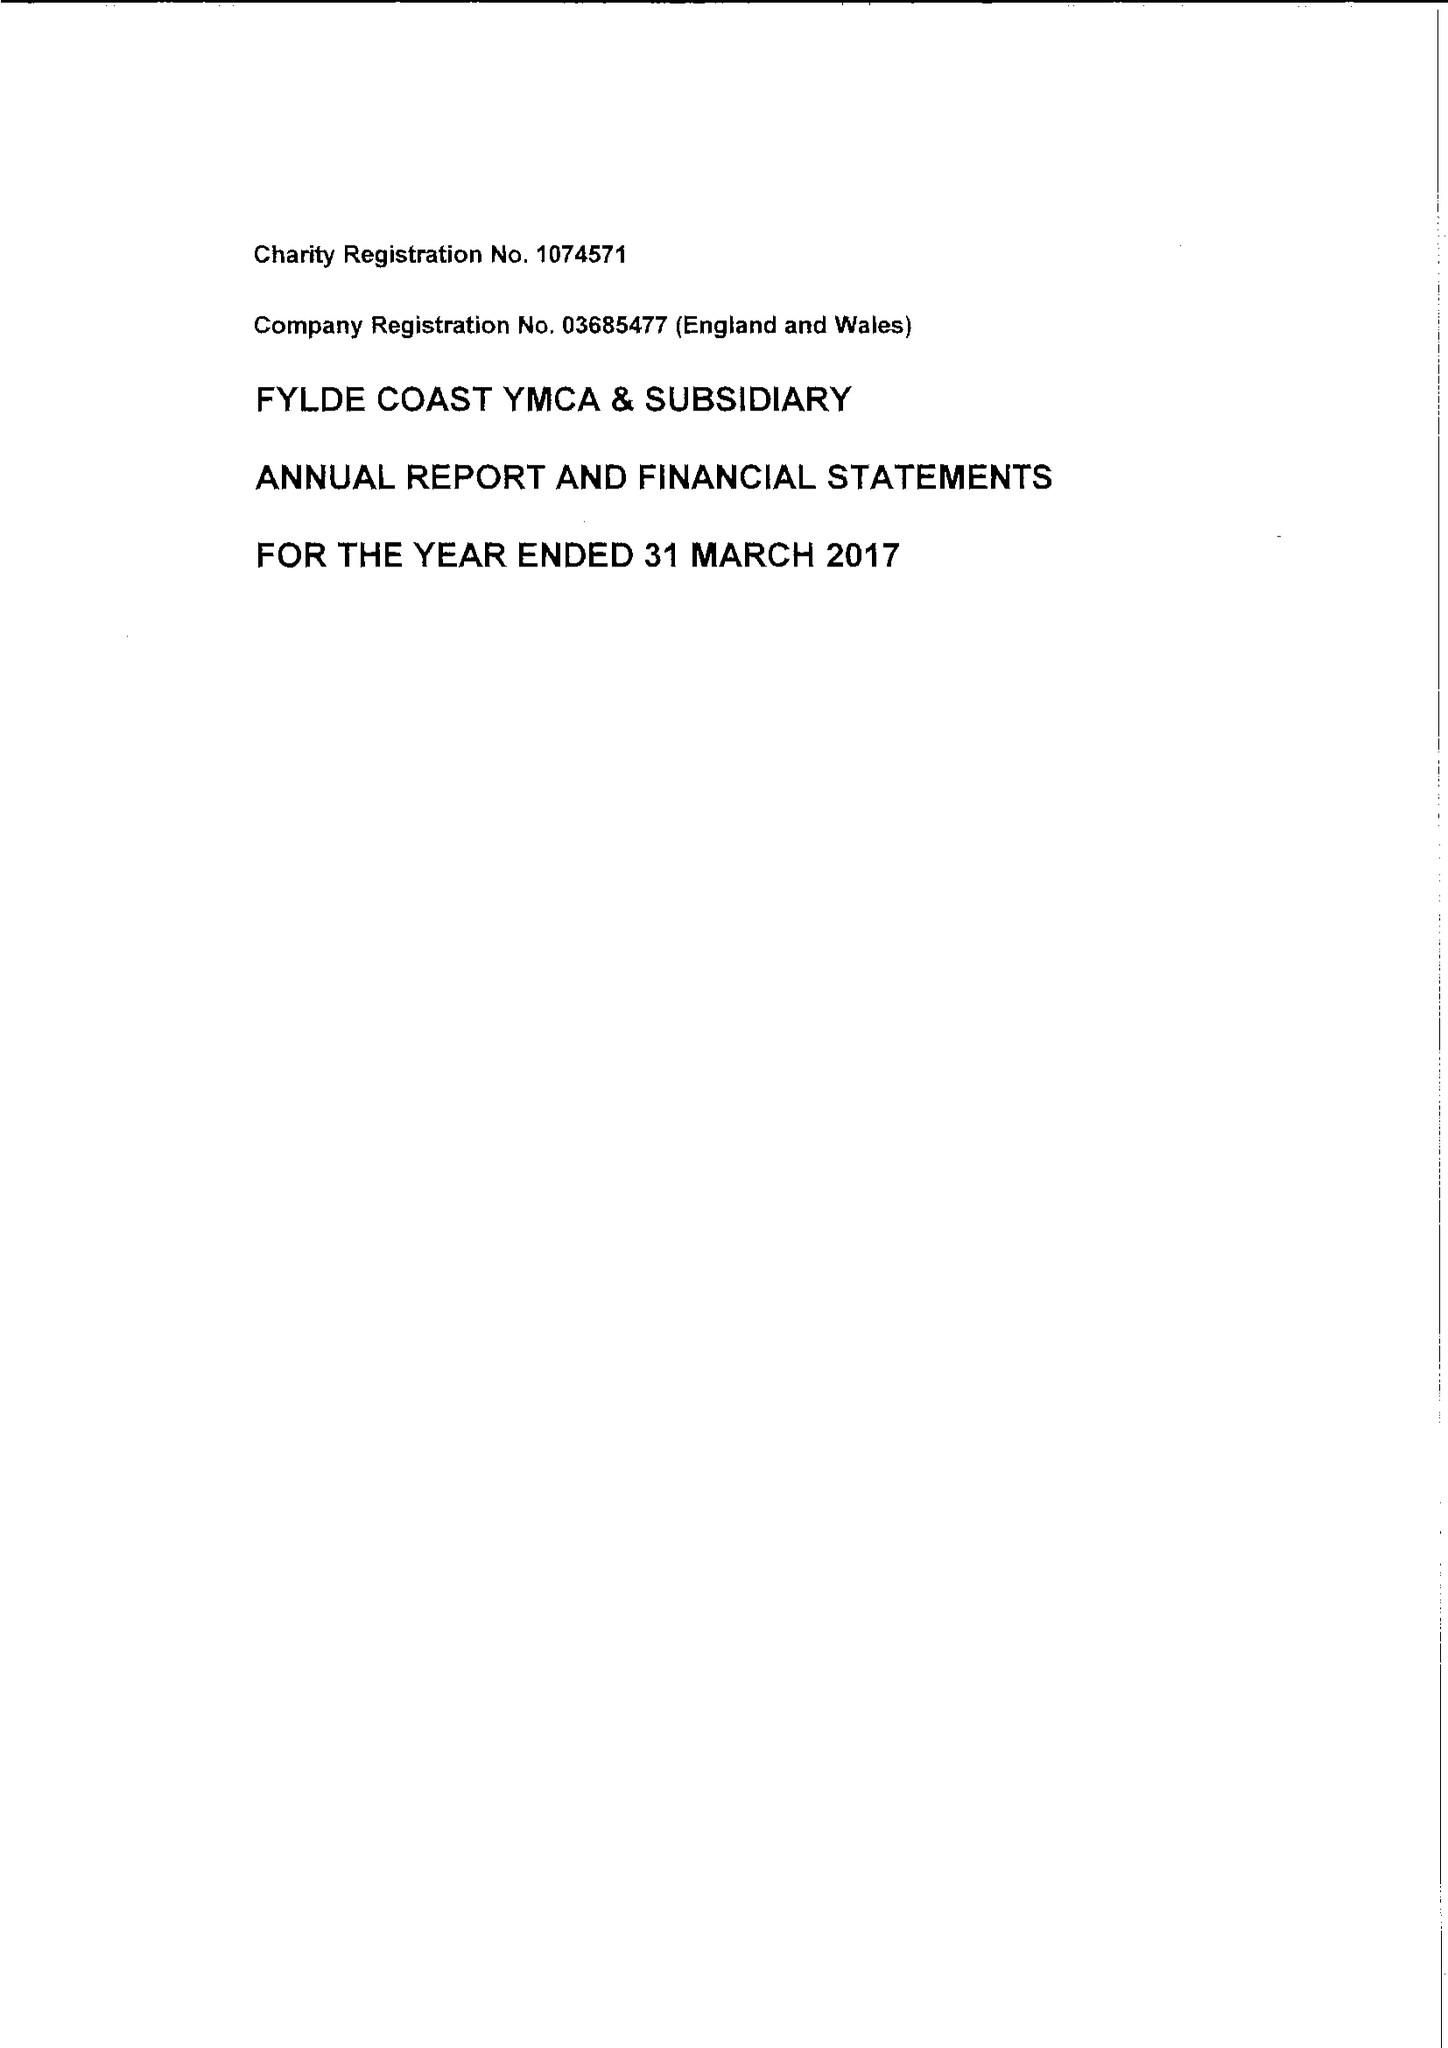What is the value for the income_annually_in_british_pounds?
Answer the question using a single word or phrase. 9551216.00 